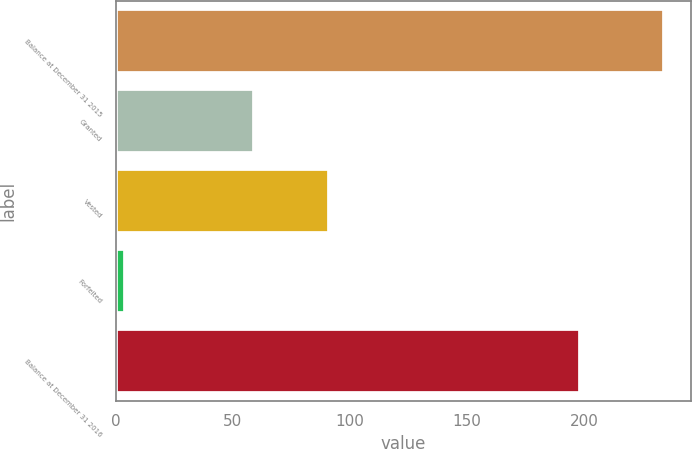Convert chart to OTSL. <chart><loc_0><loc_0><loc_500><loc_500><bar_chart><fcel>Balance at December 31 2015<fcel>Granted<fcel>Vested<fcel>Forfeited<fcel>Balance at December 31 2016<nl><fcel>234<fcel>59<fcel>91<fcel>4<fcel>198<nl></chart> 